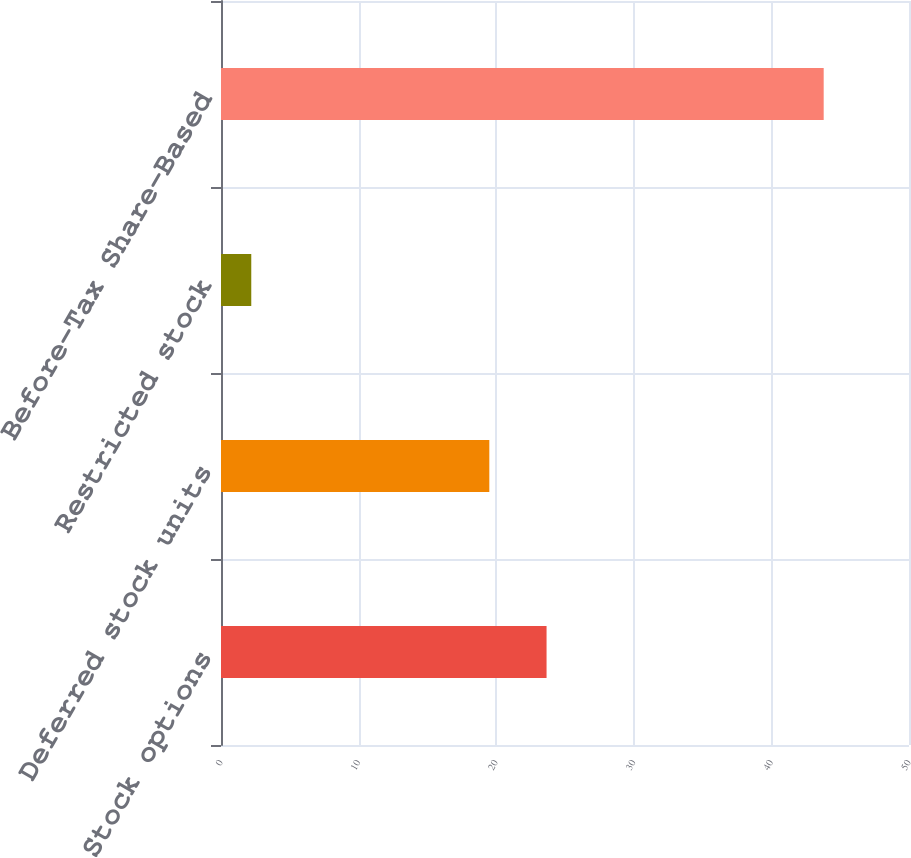<chart> <loc_0><loc_0><loc_500><loc_500><bar_chart><fcel>Stock options<fcel>Deferred stock units<fcel>Restricted stock<fcel>Before-Tax Share-Based<nl><fcel>23.66<fcel>19.5<fcel>2.2<fcel>43.8<nl></chart> 